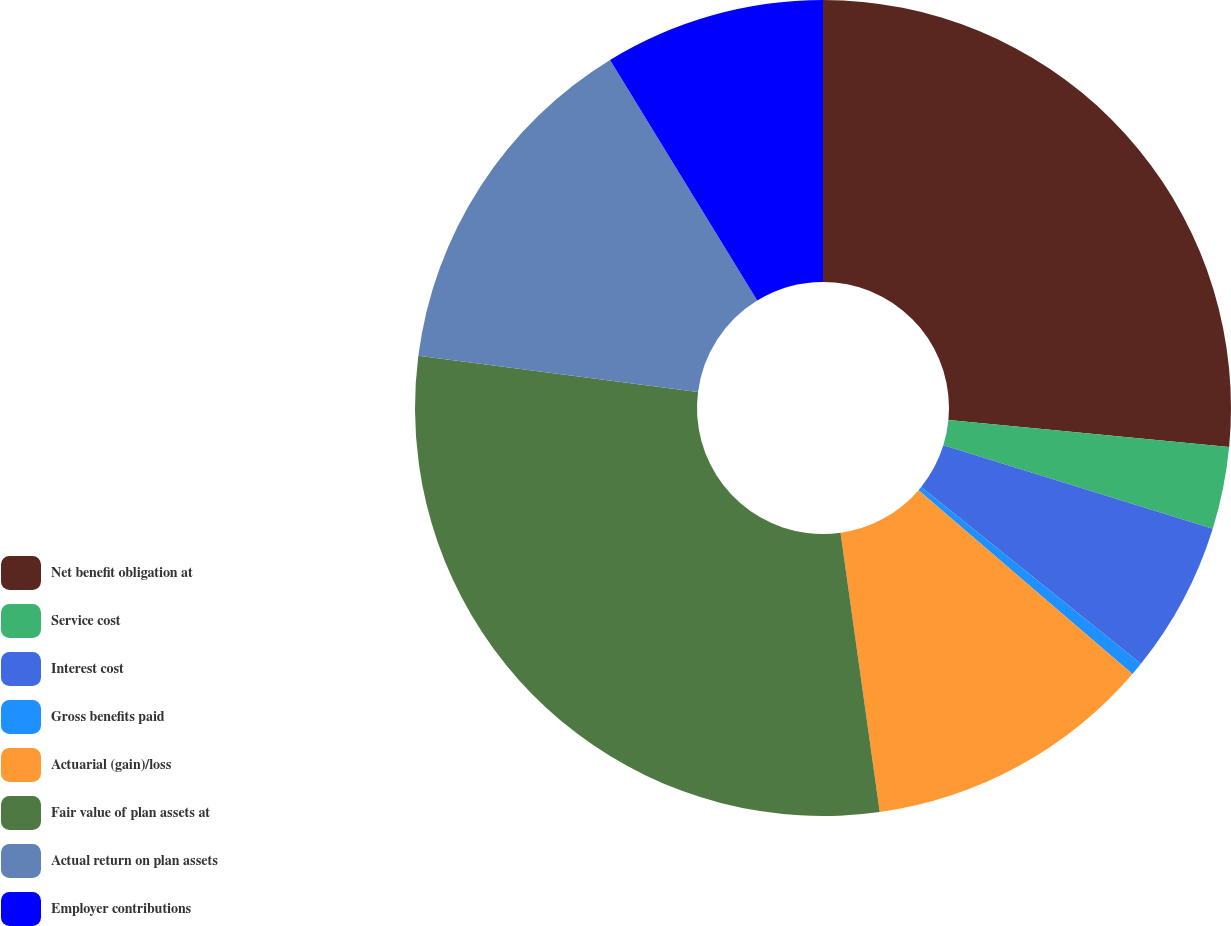Convert chart to OTSL. <chart><loc_0><loc_0><loc_500><loc_500><pie_chart><fcel>Net benefit obligation at<fcel>Service cost<fcel>Interest cost<fcel>Gross benefits paid<fcel>Actuarial (gain)/loss<fcel>Fair value of plan assets at<fcel>Actual return on plan assets<fcel>Employer contributions<nl><fcel>26.52%<fcel>3.26%<fcel>6.0%<fcel>0.52%<fcel>11.48%<fcel>29.26%<fcel>14.22%<fcel>8.74%<nl></chart> 